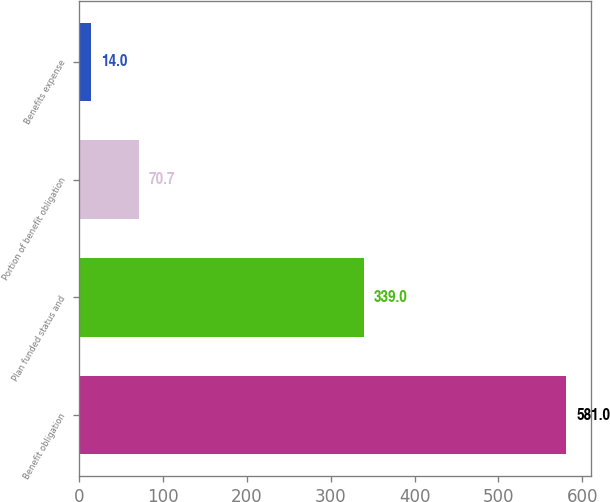<chart> <loc_0><loc_0><loc_500><loc_500><bar_chart><fcel>Benefit obligation<fcel>Plan funded status and<fcel>Portion of benefit obligation<fcel>Benefits expense<nl><fcel>581<fcel>339<fcel>70.7<fcel>14<nl></chart> 